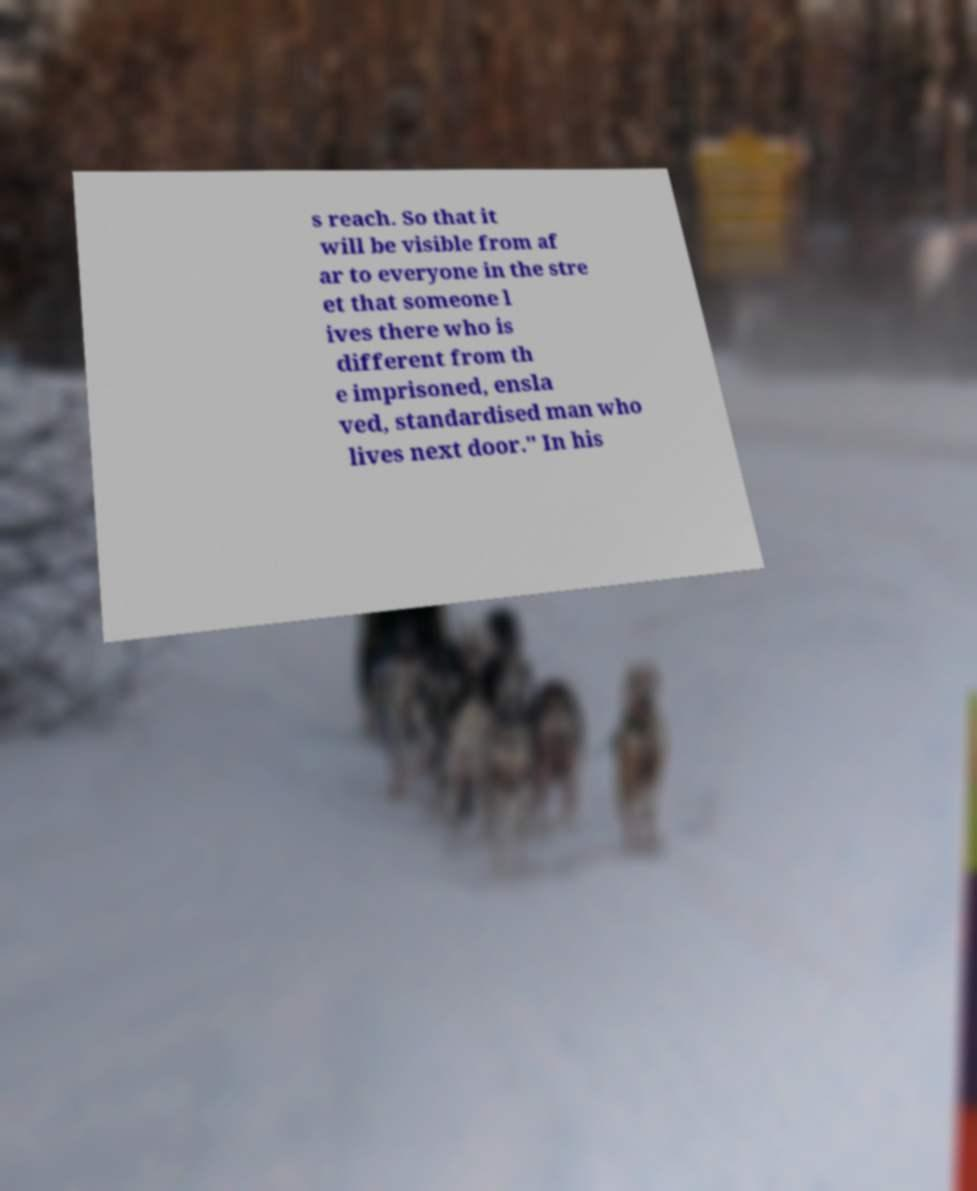Please read and relay the text visible in this image. What does it say? s reach. So that it will be visible from af ar to everyone in the stre et that someone l ives there who is different from th e imprisoned, ensla ved, standardised man who lives next door." In his 